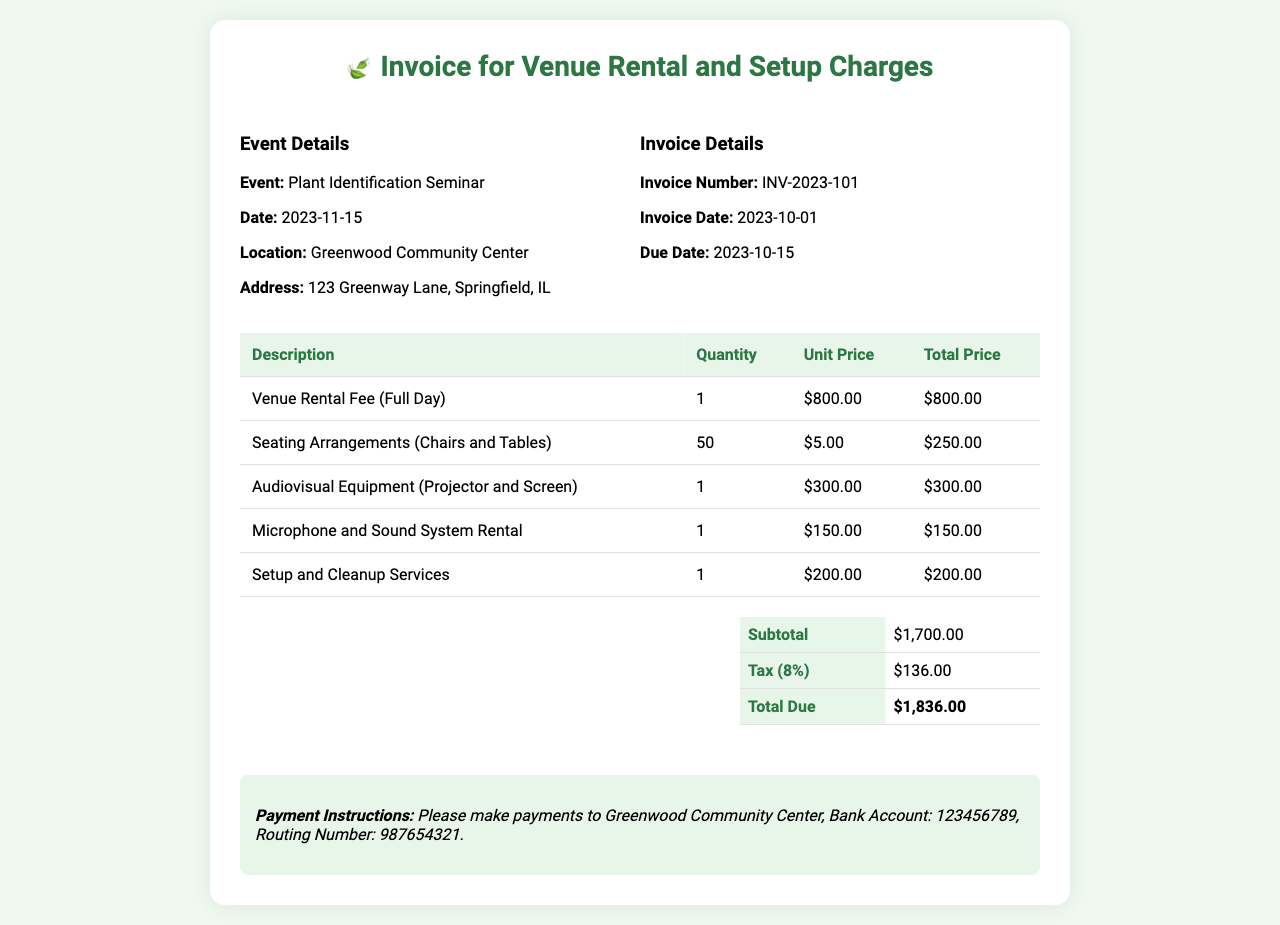what is the event title? The event title is provided in the document, which is "Plant Identification Seminar."
Answer: Plant Identification Seminar what is the date of the event? The date of the event is listed in the document as November 15, 2023.
Answer: 2023-11-15 what is the location of the event? The location of the event is specified in the document as "Greenwood Community Center."
Answer: Greenwood Community Center what is the total amount due? The total amount due is calculated in the invoice and is specified as $1,836.00.
Answer: $1,836.00 how much is the venue rental fee? The venue rental fee for a full day is detailed in the document as $800.00.
Answer: $800.00 what equipment is included in the audiovisual setup? The audiovisual equipment listed in the invoice includes a projector and screen.
Answer: Projector and Screen how many chairs and tables are included in the seating arrangements? The document specifies that there are 50 chairs and tables included in the seating arrangements.
Answer: 50 what is the tax rate applied in the invoice? The tax rate applied to the invoice is presented as 8%.
Answer: 8% when is the payment due date? The due date for payment is mentioned in the document as October 15, 2023.
Answer: 2023-10-15 